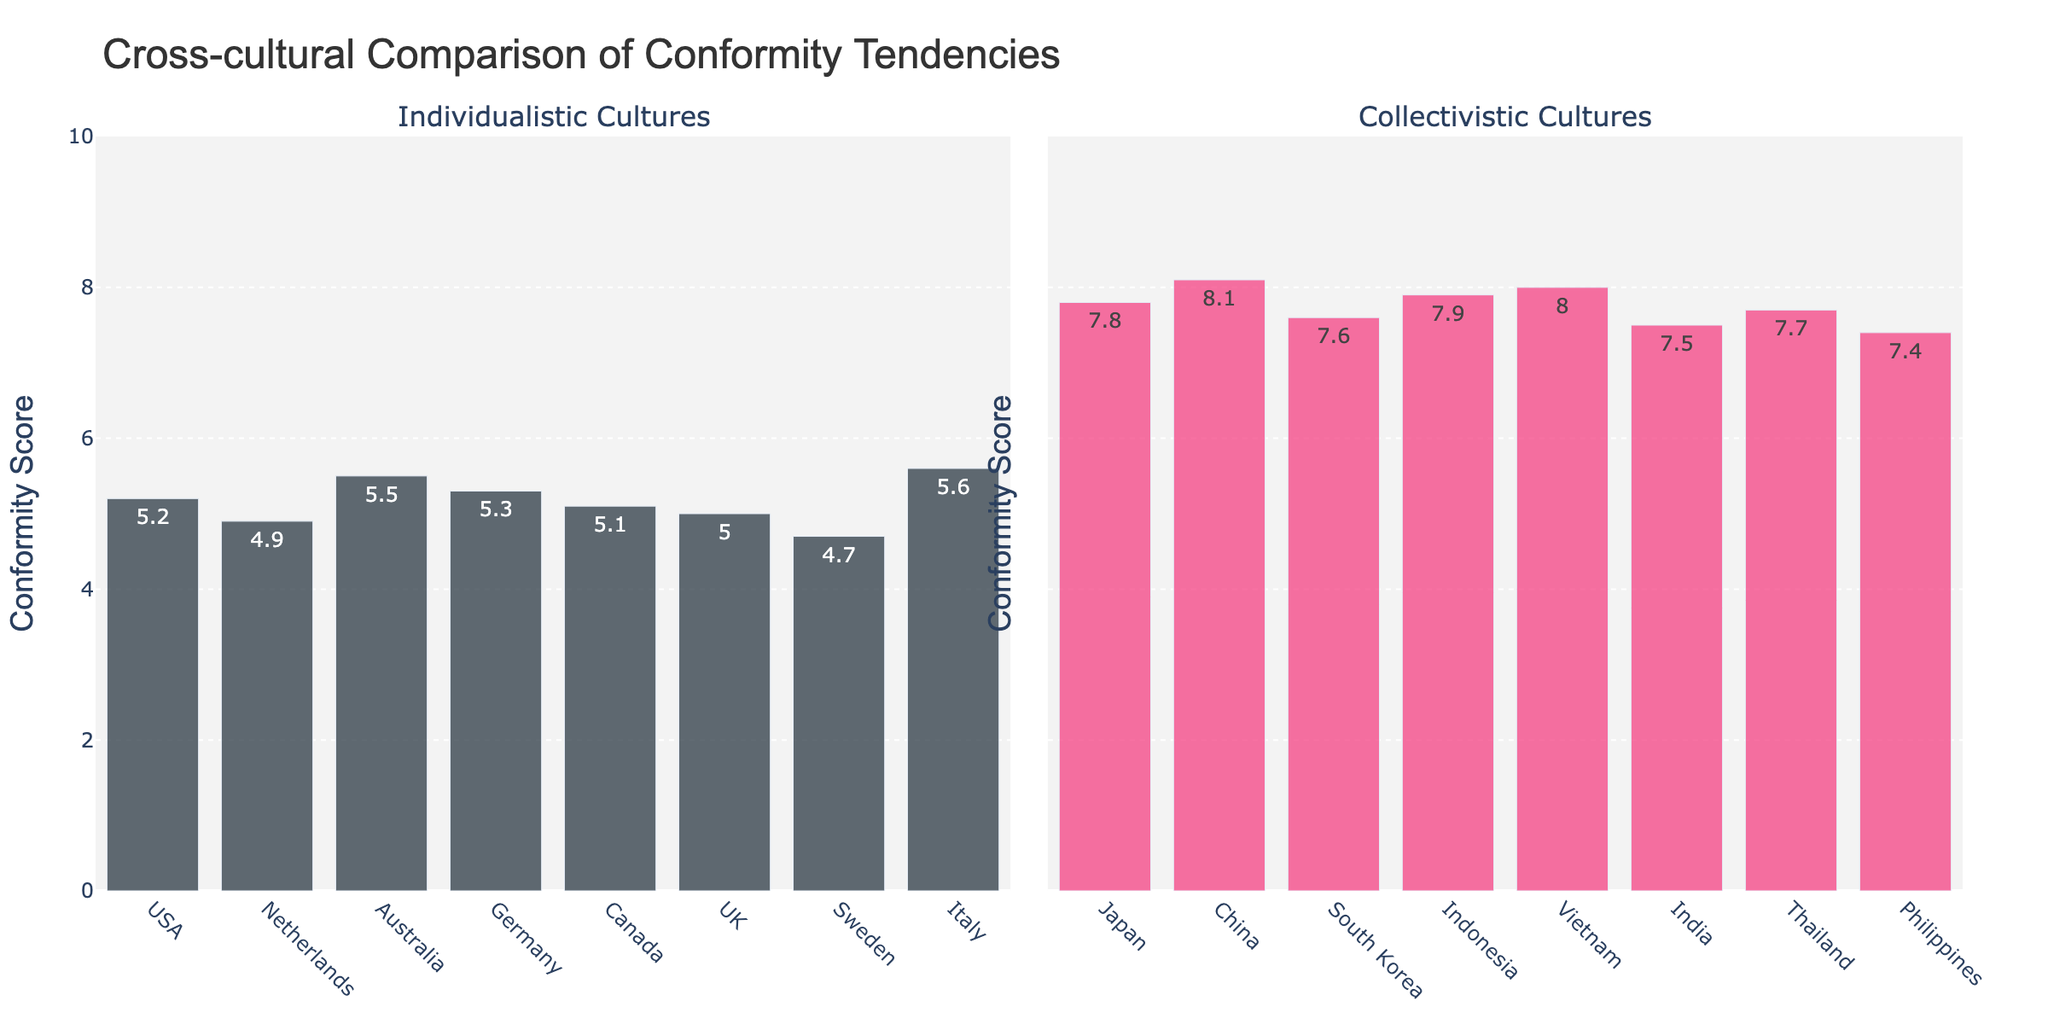What is the difference in conformity scores between the USA and Japan? To find the difference, subtract the conformity score of the USA (5.2) from that of Japan (7.8): 7.8 - 5.2 = 2.6
Answer: 2.6 Which country has the highest conformity score in collectivistic cultures? By visually inspecting the right subplot labeled "Collectivistic Cultures," identify the tallest bar. The tallest bar corresponds to China, with the score of 8.1
Answer: China Among individualistic countries, which one has the lowest conformity score? By visually inspecting the left subplot labeled "Individualistic Cultures," check for the bar with the smallest height. The shortest bar corresponds to Sweden, with a score of 4.7
Answer: Sweden What is the average conformity score of individualistic cultures shown? Sum up the conformity scores of individualistic cultures (5.2 + 4.9 + 5.5 + 5.3 + 5.1 + 5.0 + 4.7 + 5.6) and divide by the count of countries, which is 8. The sum is 41.3 and the average is 41.3 / 8 = 5.16
Answer: 5.16 Which culture type shows higher conformity scores on average? First, calculate the average score for each culture type: Individualistic (sum is 41.3, number of countries is 8, so average 41.3 / 8 = 5.16) and Collectivistic (sum is 60, number of countries is 8, so average 60 / 8 = 7.5). Compare the averages and note that 7.5 > 5.16
Answer: Collectivistic What is the range of conformity scores for collectivistic cultures? Determine the lowest and highest conformity scores for collectivistic cultures. The lowest score is for the Philippines (7.4) and the highest score is for China (8.1). The range is 8.1 - 7.4 = 0.7
Answer: 0.7 Is there any country with a conformity score equal to 5.3? Look at both subplots to find a bar associated with the score 5.3. Germany has a score of 5.3 in the individualistic subplot
Answer: Germany What is the sum of conformity scores for countries in the collectivistic group with scores above 7.6? Identify and sum the scores above 7.6: Japan (7.8), China (8.1), Indonesia (7.9), Vietnam (8.0), and Thailand (7.7). The sum is 7.8 + 8.1 + 7.9 + 8.0 + 7.7 = 39.5
Answer: 39.5 Which country among the individualistic ones has the closest conformity score to the average of collectivistic countries? The average score for collectivistic countries is 7.5. Compare this with individualistic scores: 5.2 (USA), 4.9 (Netherlands), 5.5 (Australia), 5.3 (Germany), 5.1 (Canada), 5.0 (UK), 4.7 (Sweden), 5.6 (Italy). The closest score from individualistic countries is 5.6 (Italy)
Answer: Italy 